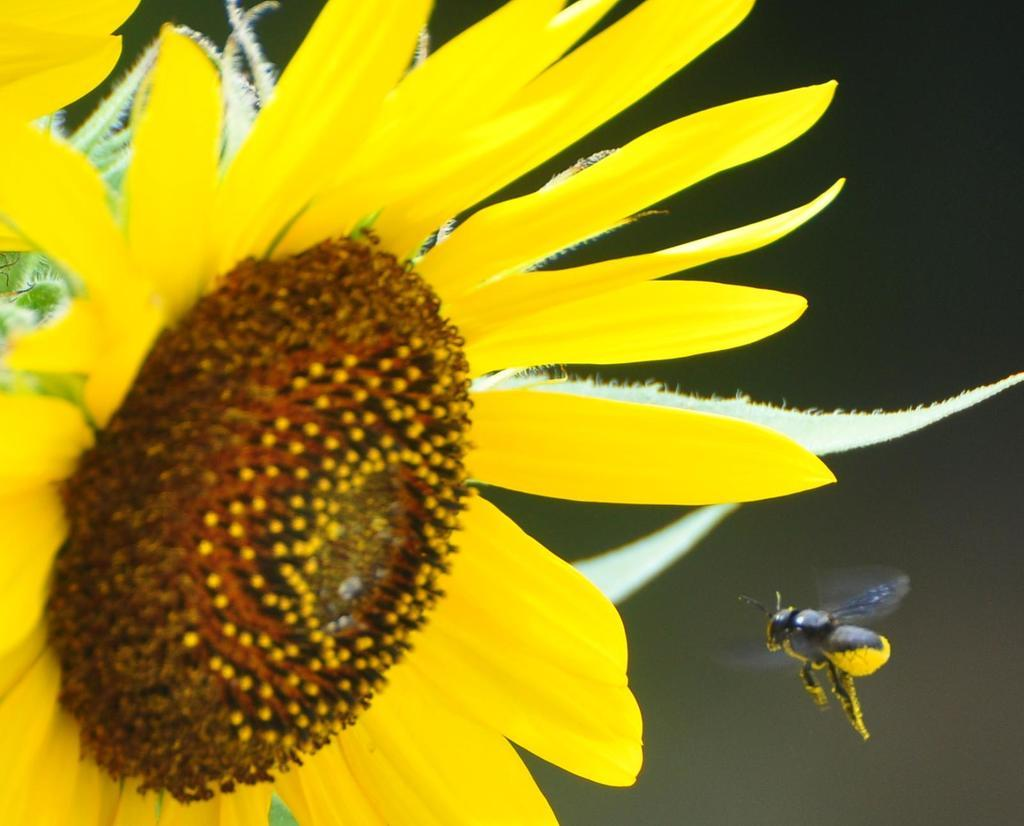What is present in the image that represents a living organism? There is a flower and a bee in the image. Can you describe the relationship between the flower and the bee in the image? The bee is likely interacting with the flower, as bees are known to collect nectar from flowers. What type of control system is being used to manage the bushes in the image? There are no bushes present in the image, and therefore no control system is needed or visible. 